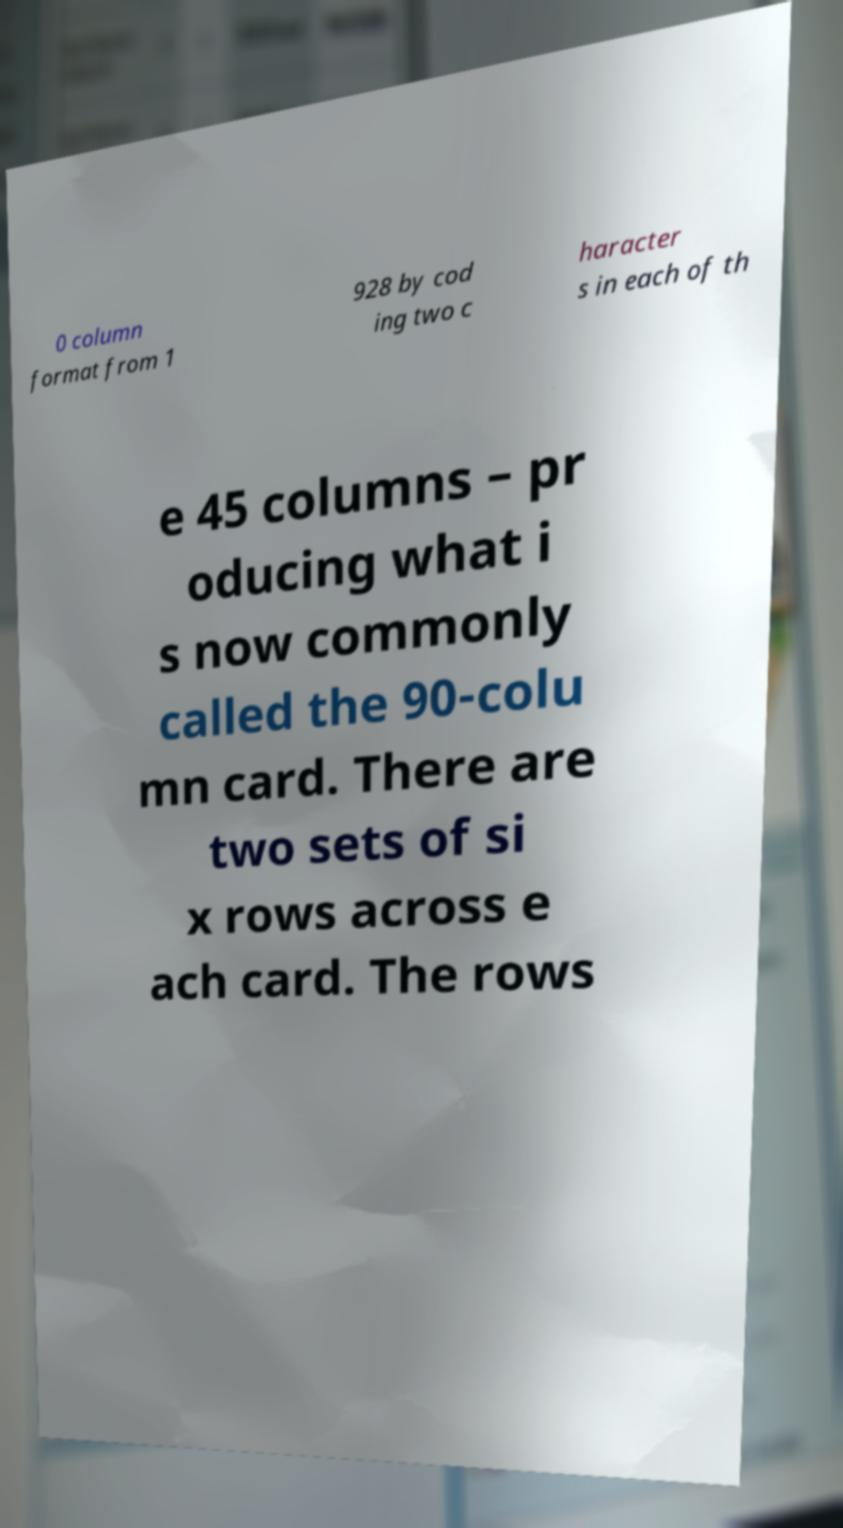Please identify and transcribe the text found in this image. 0 column format from 1 928 by cod ing two c haracter s in each of th e 45 columns – pr oducing what i s now commonly called the 90-colu mn card. There are two sets of si x rows across e ach card. The rows 